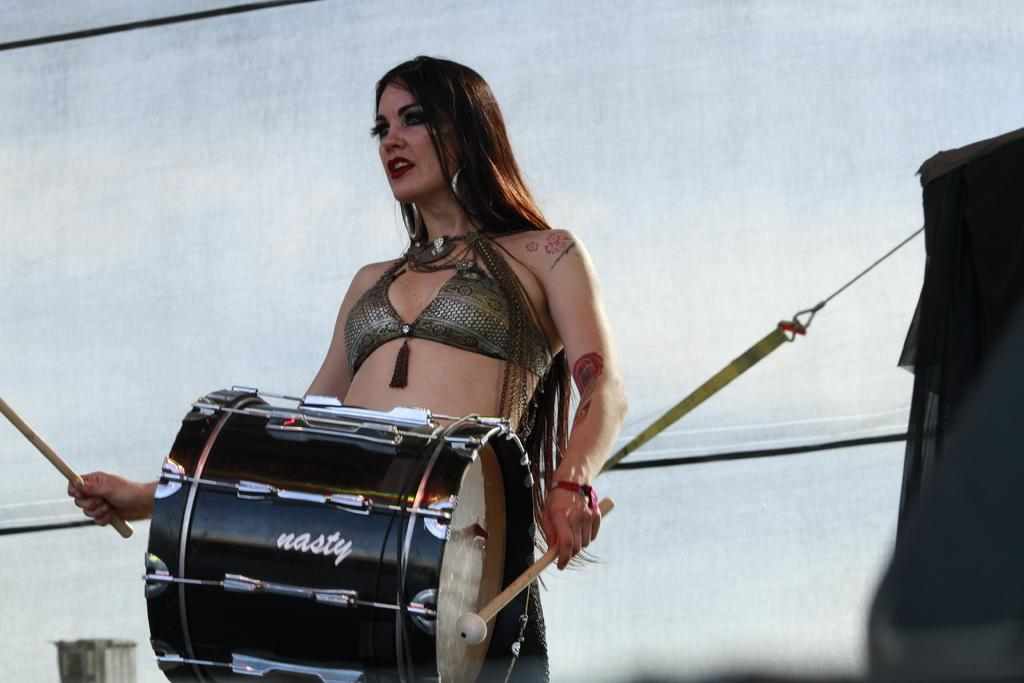What is the main subject of the image? There is a person in the image. What is the person holding in the image? The person is holding sticks. What object is in front of the person? There is a drum in front of the person. What color is the background of the image? The background of the image is white. Can you see any robin or fairies interacting with the person in the image? No, there are no robin or fairies present in the image. What type of fork is the person using to play the drum in the image? There is no fork visible in the image, and the person is not using any fork to play the drum. 